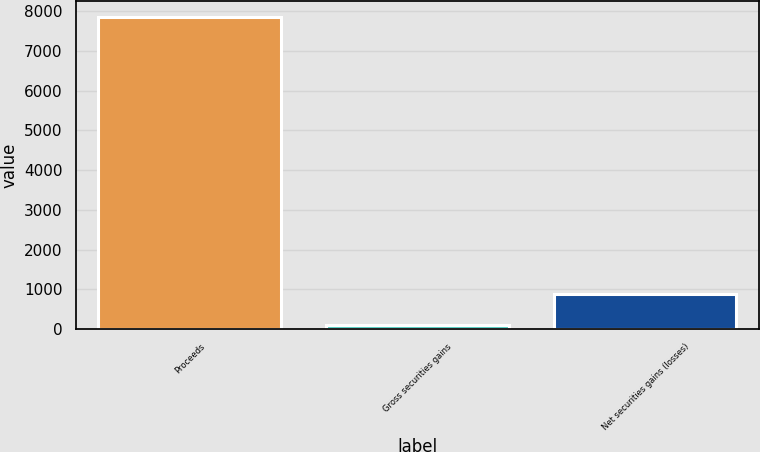Convert chart. <chart><loc_0><loc_0><loc_500><loc_500><bar_chart><fcel>Proceeds<fcel>Gross securities gains<fcel>Net securities gains (losses)<nl><fcel>7859<fcel>112<fcel>886.7<nl></chart> 